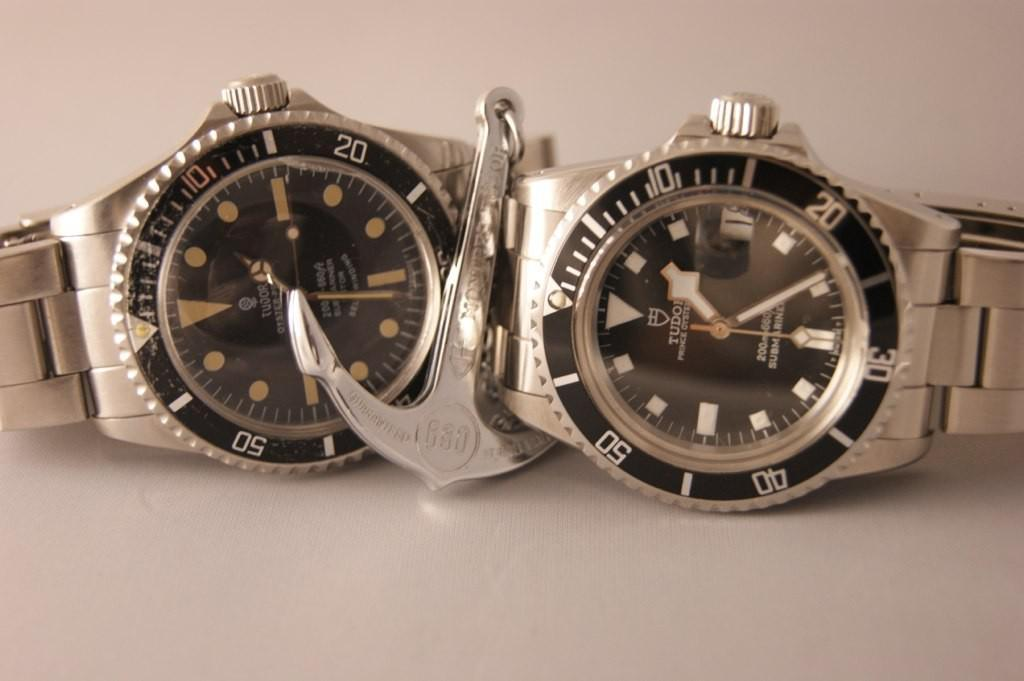<image>
Describe the image concisely. The silver watch here is from the company Tudor 